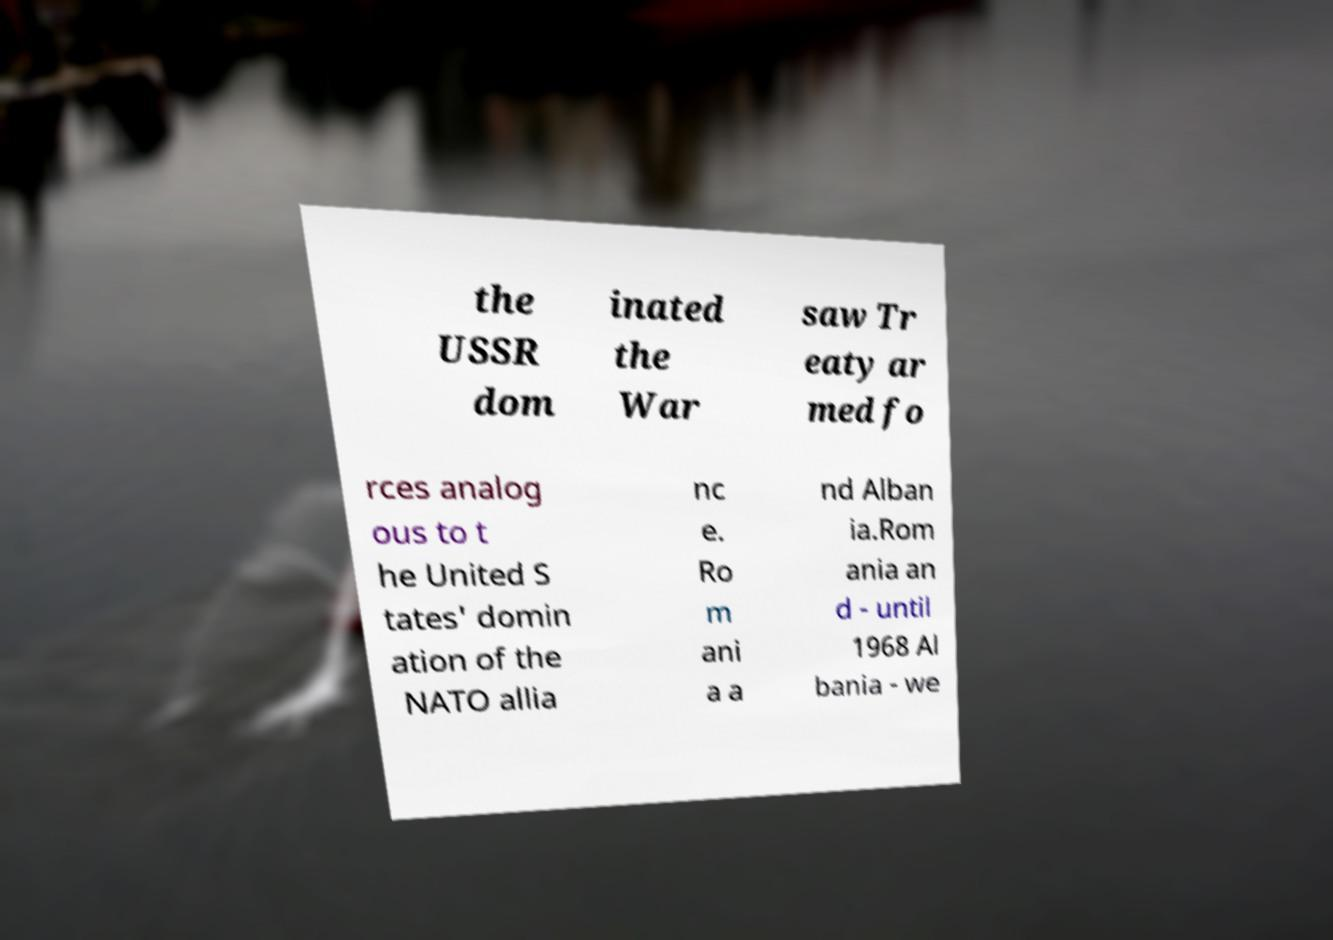I need the written content from this picture converted into text. Can you do that? the USSR dom inated the War saw Tr eaty ar med fo rces analog ous to t he United S tates' domin ation of the NATO allia nc e. Ro m ani a a nd Alban ia.Rom ania an d - until 1968 Al bania - we 